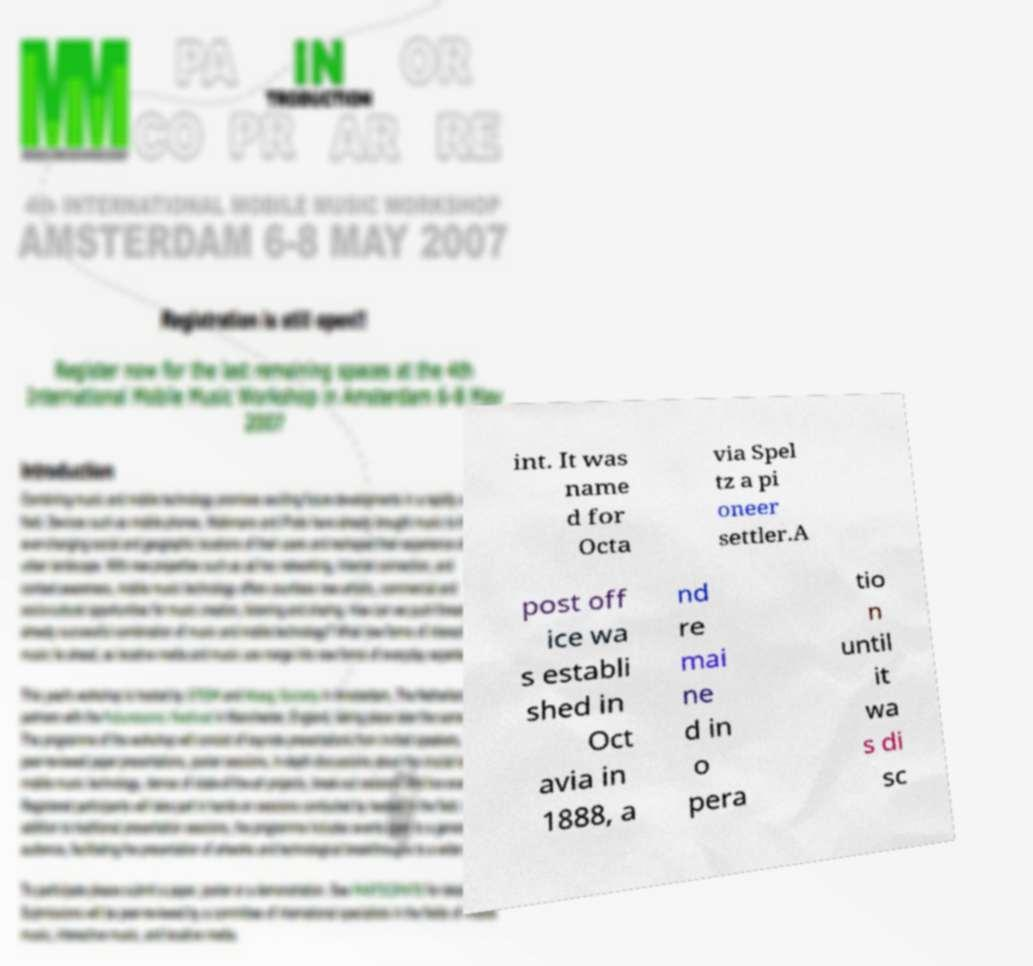For documentation purposes, I need the text within this image transcribed. Could you provide that? int. It was name d for Octa via Spel tz a pi oneer settler.A post off ice wa s establi shed in Oct avia in 1888, a nd re mai ne d in o pera tio n until it wa s di sc 